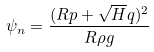<formula> <loc_0><loc_0><loc_500><loc_500>\psi _ { n } = \frac { ( R p + \sqrt { H } q ) ^ { 2 } } { R \rho g }</formula> 